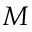<formula> <loc_0><loc_0><loc_500><loc_500>M</formula> 